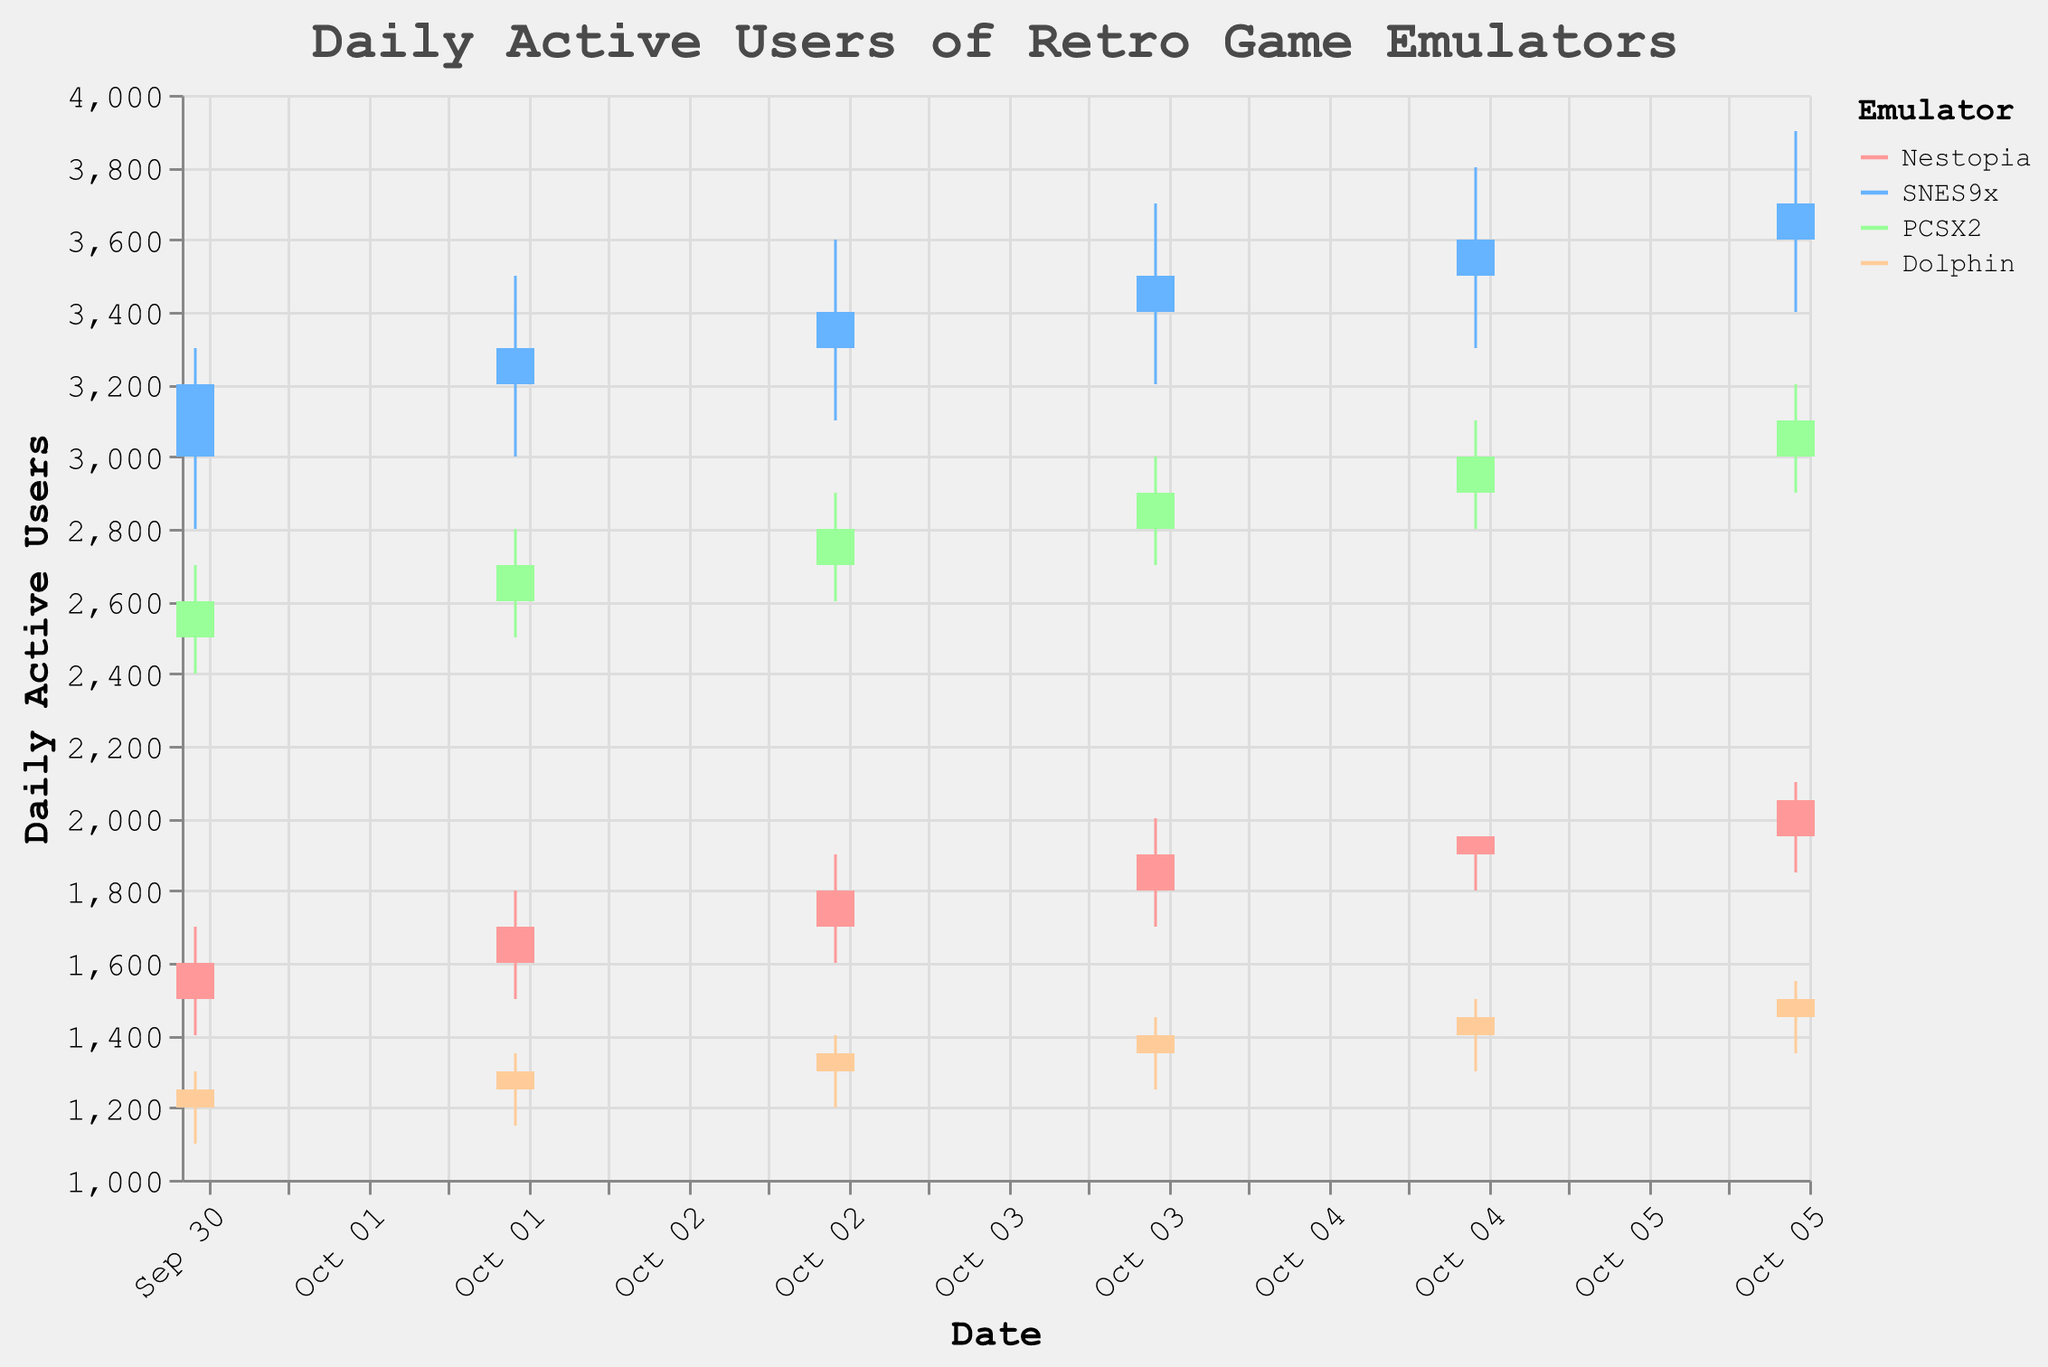What is the title of the candlestick plot? The title is usually displayed at the top of the graph. In this case, according to the provided code, the title is "Daily Active Users of Retro Game Emulators."
Answer: Daily Active Users of Retro Game Emulators Which emulator had the highest number of daily active users on October 1st, 2023? To determine this, look for the bars corresponding to October 1st for each emulator and compare their heights. Specifically, compare the closing values for Nestopia, SNES9x, PCSX2, and Dolphin. The highest closing value is 3200 for SNES9x.
Answer: SNES9x What was the range of daily active users for PCSX2 on October 4th? The range is calculated as the difference between the highest (3000) and lowest (2700) values for that day.
Answer: 300 On which day did Dolphin have the highest closing value? Check the closing values of Dolphin for each day and identify the highest one. The values are 1250, 1300, 1350, 1400, 1450, and 1500. The highest closing value is 1500 on October 6th.
Answer: October 6th How does the trend of daily active users for Nestopia from October 1st to October 6th compare to that of Dolphin over the same period? Observe the trendlines for both emulators. Nestopia shows a general increase from 1500 to 2050, while Dolphin also increases steadily from 1250 to 1500. Both show an upward trend, but Nestopia has more fluctuations and a greater overall increase.
Answer: Both have upward trends; Nestopia fluctuates more and increases more overall What are the start and end values of SNES9x on October 3rd? Locate the bar for SNES9x on October 3rd. The start value (Open) is 3300, and the end value (Close) is 3400.
Answer: Open: 3300, Close: 3400 Which emulator had the most stable number of daily active users over the six days? Stability can be observed by looking at the fluctuations in the closing values of each emulator. Smaller fluctuations indicate greater stability. Comparing the differences:
Nestopia: Fluctuates between 1600 and 2050
SNES9x: Fluctuates between 3200 and 3700
PCSX2: Fluctuates between 2600 and 3100
Dolphin: Fluctuates between 1250 and 1500
Dolphin shows the least variation, so it's the most stable.
Answer: Dolphin What is the average closing value for PCSX2 over the fixed period in the plot? Add the closing values from October 1st to October 6th: 2600, 2700, 2800, 2900, 3000, and 3100. Sum = 17100. There are six days, so the average is 17100/6.
Answer: 2850 Compare the closing value of Dolphin on October 2nd with the opening value of Dolphin on October 3rd. Find the closing value for Dolphin on October 2nd (1300) and the opening value on October 3rd (1300). Notice both values are the same.
Answer: Equal Which emulator had the highest peak (highest high value) during the observed period? Compare the highest high values across all emulators. The highest values are:
Nestopia: 2100
SNES9x: 3900
PCSX2: 3200
Dolphin: 1550
SNES9x has the highest peak at 3900.
Answer: SNES9x 